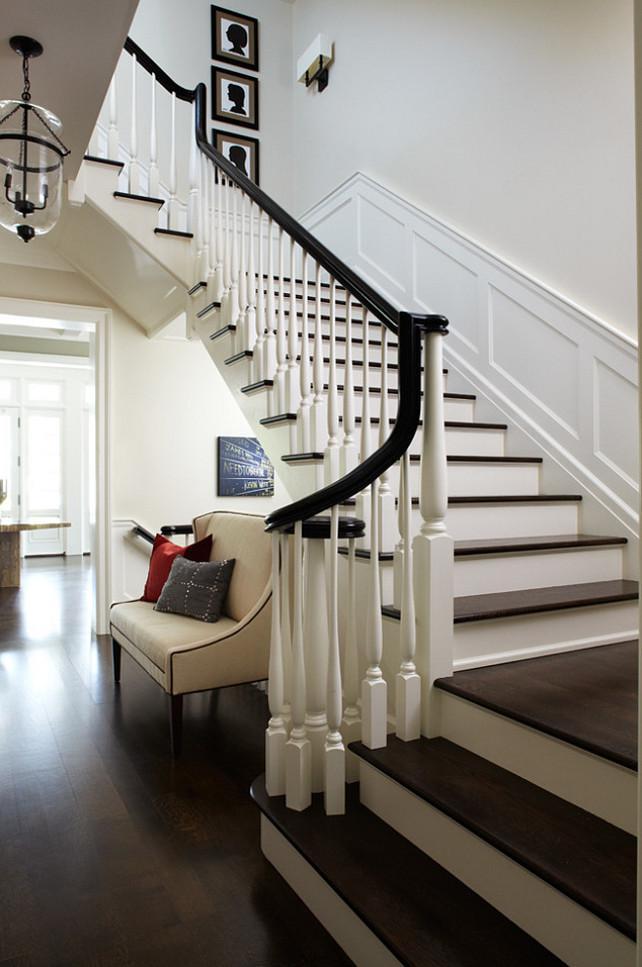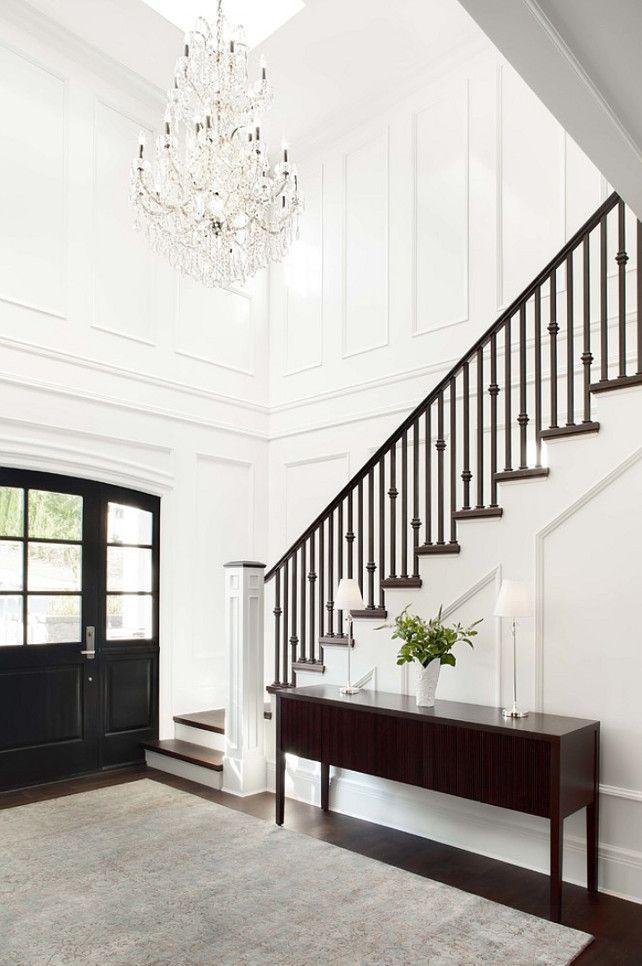The first image is the image on the left, the second image is the image on the right. Considering the images on both sides, is "One image shows a staircase that curves to the left as it descends and has brown steps with white base boards and a black handrail." valid? Answer yes or no. Yes. The first image is the image on the left, the second image is the image on the right. Assess this claim about the two images: "There is at least one vase with white flowers in it sitting on a table.". Correct or not? Answer yes or no. No. 